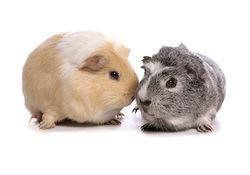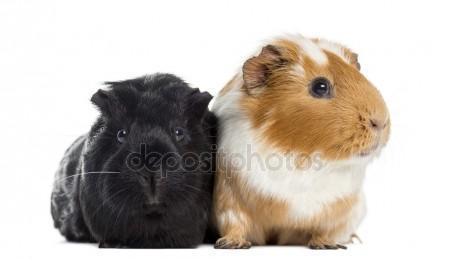The first image is the image on the left, the second image is the image on the right. Analyze the images presented: Is the assertion "There are  4 guinea pigs in the pair" valid? Answer yes or no. Yes. 